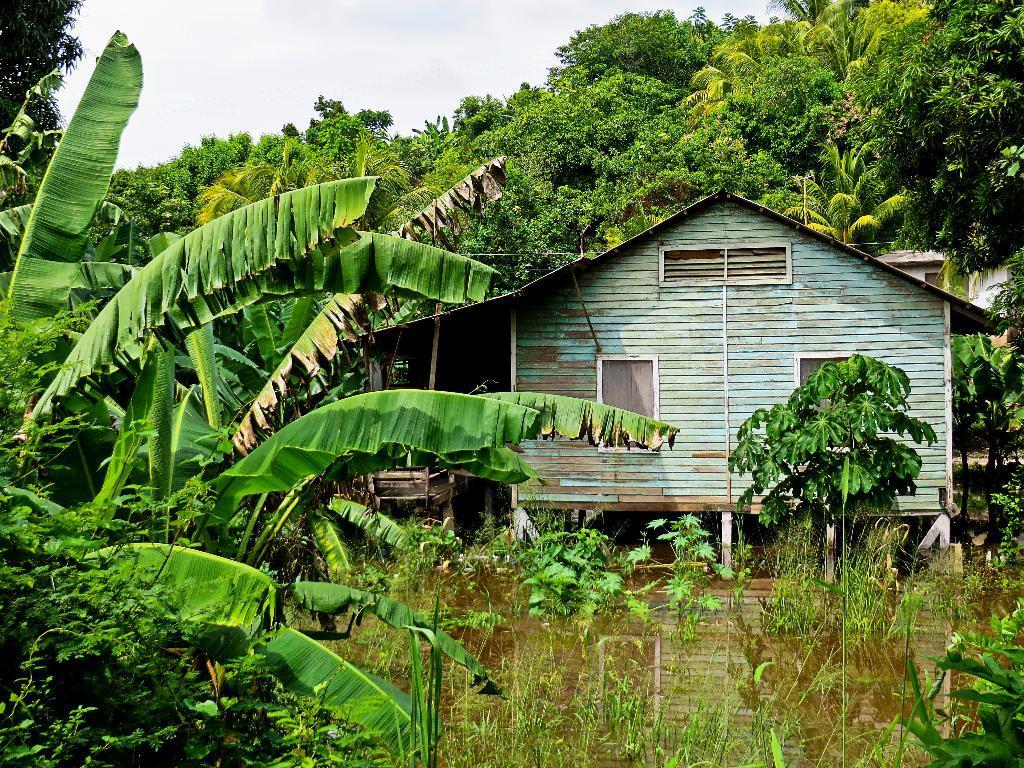Describe this image in one or two sentences. In the center of the image we can see the sky, trees, one building, one wooden house, plants and water. And we can see the reflection of a wooden house on the water. 